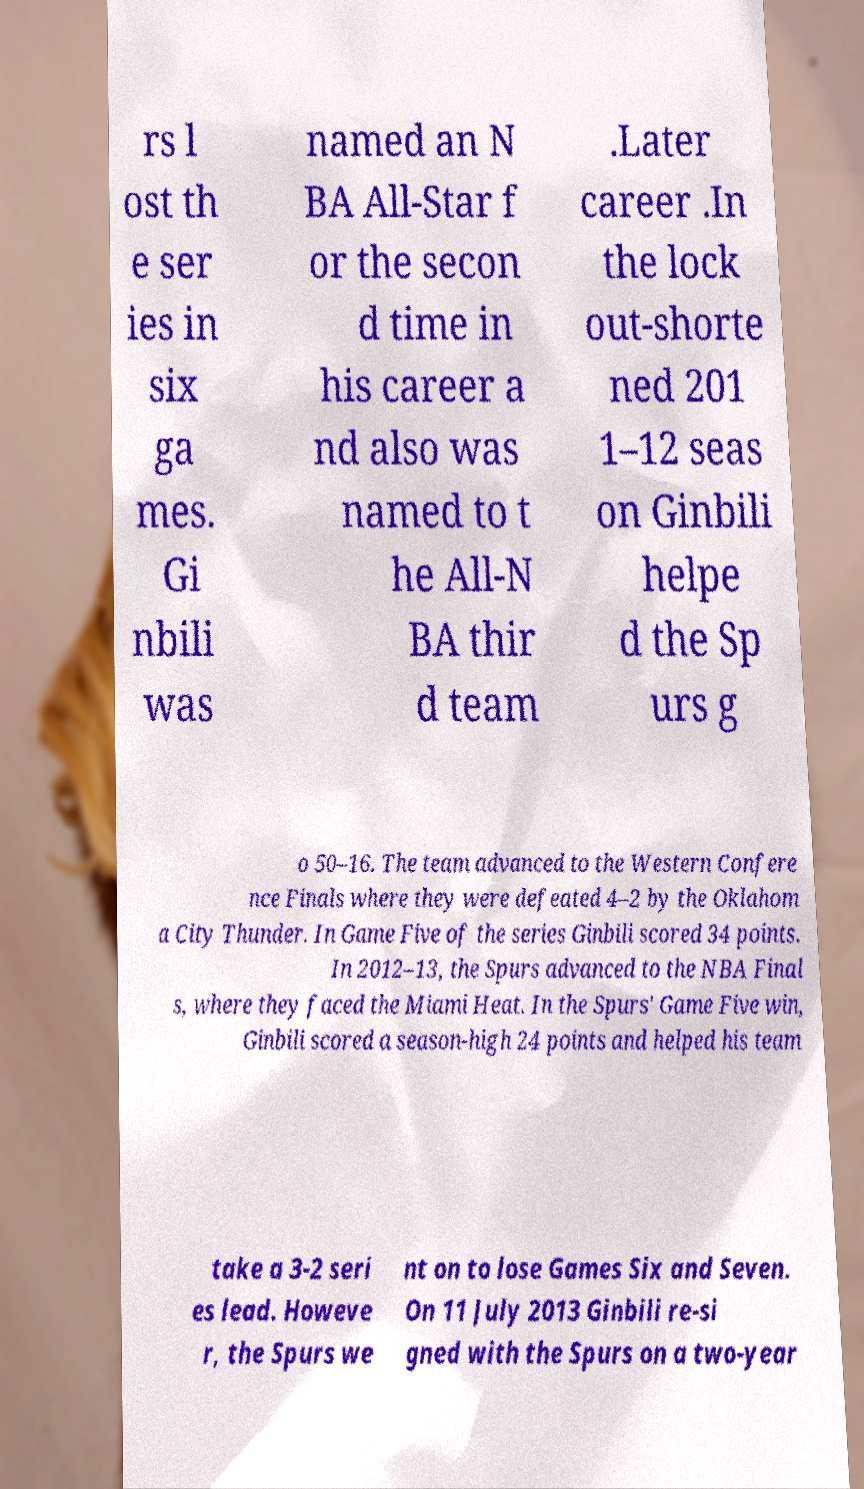For documentation purposes, I need the text within this image transcribed. Could you provide that? rs l ost th e ser ies in six ga mes. Gi nbili was named an N BA All-Star f or the secon d time in his career a nd also was named to t he All-N BA thir d team .Later career .In the lock out-shorte ned 201 1–12 seas on Ginbili helpe d the Sp urs g o 50–16. The team advanced to the Western Confere nce Finals where they were defeated 4–2 by the Oklahom a City Thunder. In Game Five of the series Ginbili scored 34 points. In 2012–13, the Spurs advanced to the NBA Final s, where they faced the Miami Heat. In the Spurs' Game Five win, Ginbili scored a season-high 24 points and helped his team take a 3-2 seri es lead. Howeve r, the Spurs we nt on to lose Games Six and Seven. On 11 July 2013 Ginbili re-si gned with the Spurs on a two-year 